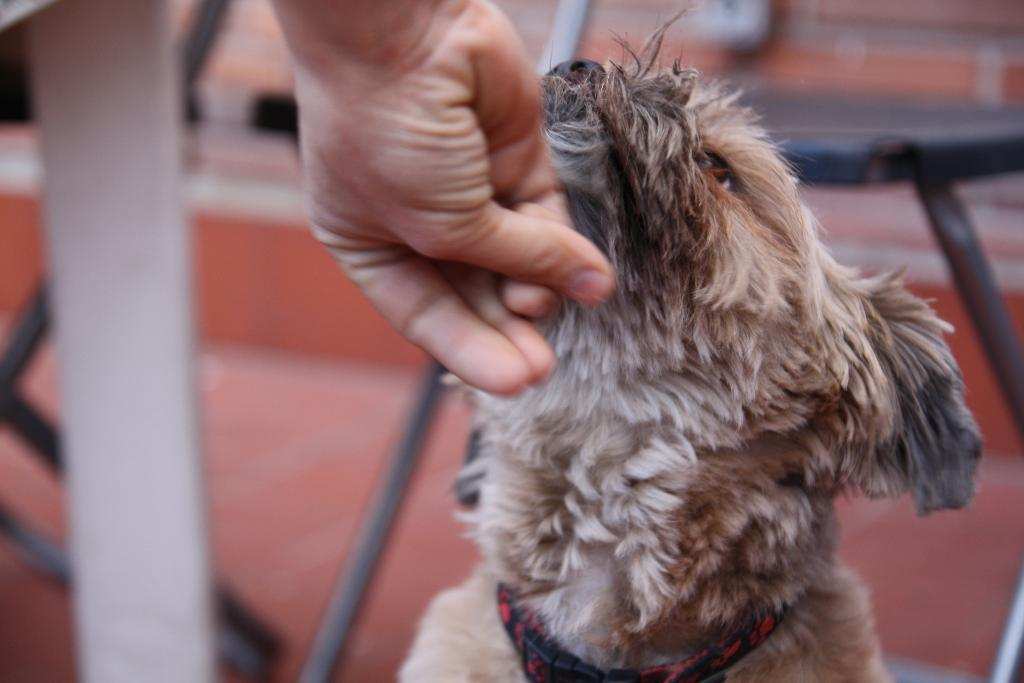What type of animal is in the image? There is a dog in the image. What part of a person is visible in the image? There is a person's hand visible in the image. What type of furniture is in the image? There are chairs in the image. What architectural feature is in the image? There is a staircase in the image. What color is the background of the image? The background of the image has an orange color. How many fairies are sitting on the dog in the image? There are no fairies present in the image; it only features a dog, a person's hand, chairs, a staircase, and an orange background. 